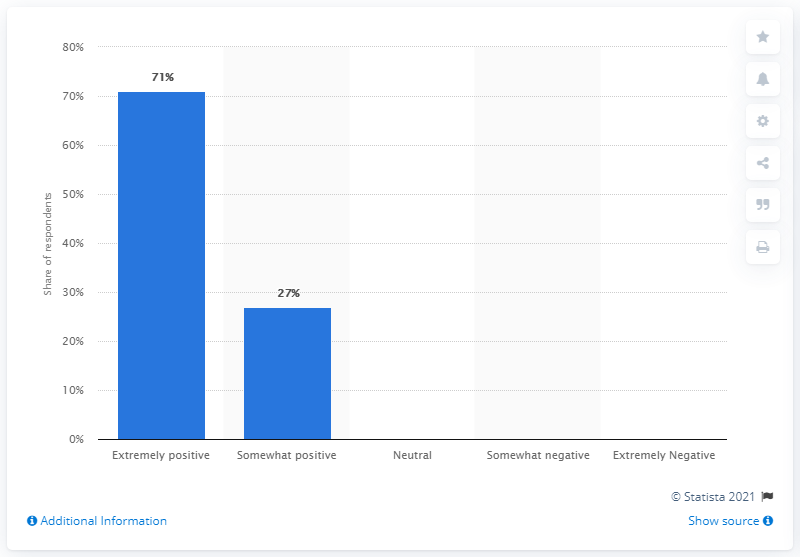Indicate a few pertinent items in this graphic. According to a survey of consumers, 71% of respondents rated The North Face's footwear as extremely positive. 